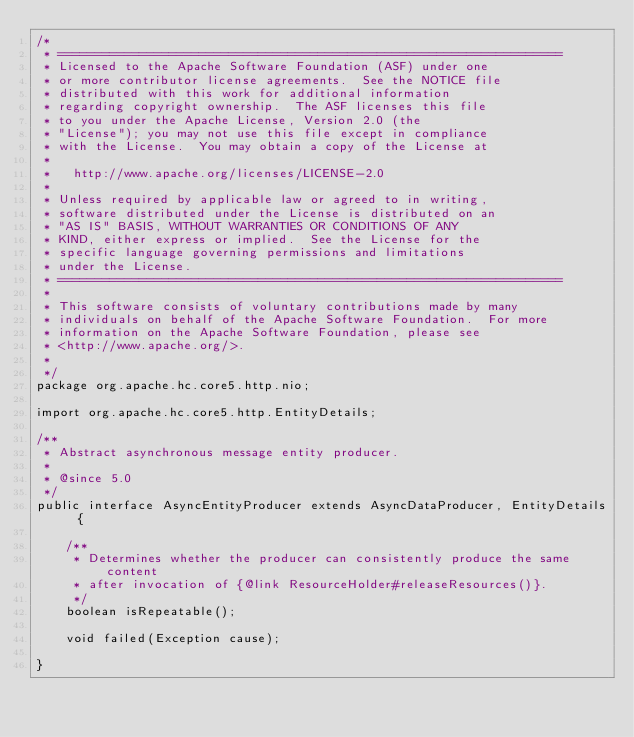<code> <loc_0><loc_0><loc_500><loc_500><_Java_>/*
 * ====================================================================
 * Licensed to the Apache Software Foundation (ASF) under one
 * or more contributor license agreements.  See the NOTICE file
 * distributed with this work for additional information
 * regarding copyright ownership.  The ASF licenses this file
 * to you under the Apache License, Version 2.0 (the
 * "License"); you may not use this file except in compliance
 * with the License.  You may obtain a copy of the License at
 *
 *   http://www.apache.org/licenses/LICENSE-2.0
 *
 * Unless required by applicable law or agreed to in writing,
 * software distributed under the License is distributed on an
 * "AS IS" BASIS, WITHOUT WARRANTIES OR CONDITIONS OF ANY
 * KIND, either express or implied.  See the License for the
 * specific language governing permissions and limitations
 * under the License.
 * ====================================================================
 *
 * This software consists of voluntary contributions made by many
 * individuals on behalf of the Apache Software Foundation.  For more
 * information on the Apache Software Foundation, please see
 * <http://www.apache.org/>.
 *
 */
package org.apache.hc.core5.http.nio;

import org.apache.hc.core5.http.EntityDetails;

/**
 * Abstract asynchronous message entity producer.
 *
 * @since 5.0
 */
public interface AsyncEntityProducer extends AsyncDataProducer, EntityDetails {

    /**
     * Determines whether the producer can consistently produce the same content
     * after invocation of {@link ResourceHolder#releaseResources()}.
     */
    boolean isRepeatable();

    void failed(Exception cause);

}
</code> 